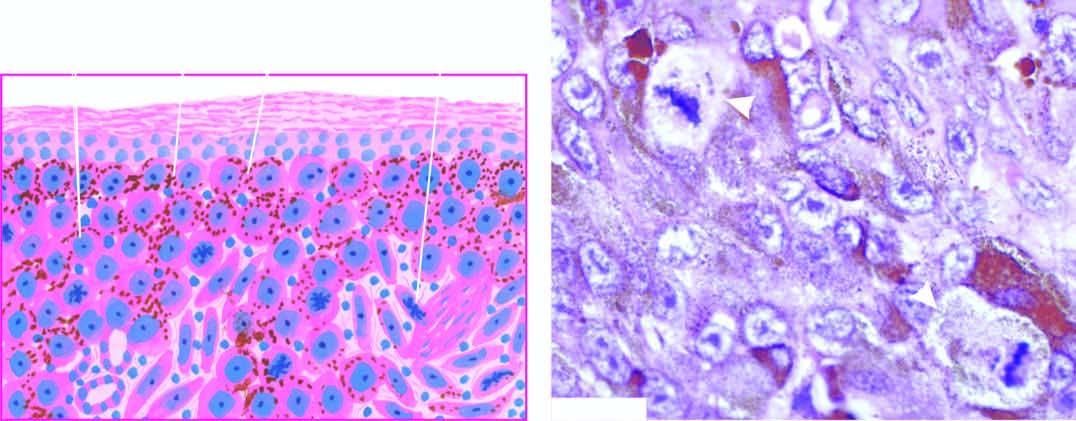what does malignant melanoma show at the dermal-epidermal junction?
Answer the question using a single word or phrase. Junctional activity 